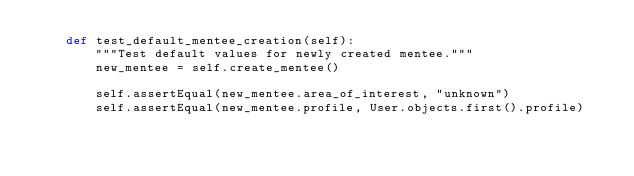Convert code to text. <code><loc_0><loc_0><loc_500><loc_500><_Python_>    def test_default_mentee_creation(self):
        """Test default values for newly created mentee."""
        new_mentee = self.create_mentee()

        self.assertEqual(new_mentee.area_of_interest, "unknown")
        self.assertEqual(new_mentee.profile, User.objects.first().profile)
</code> 